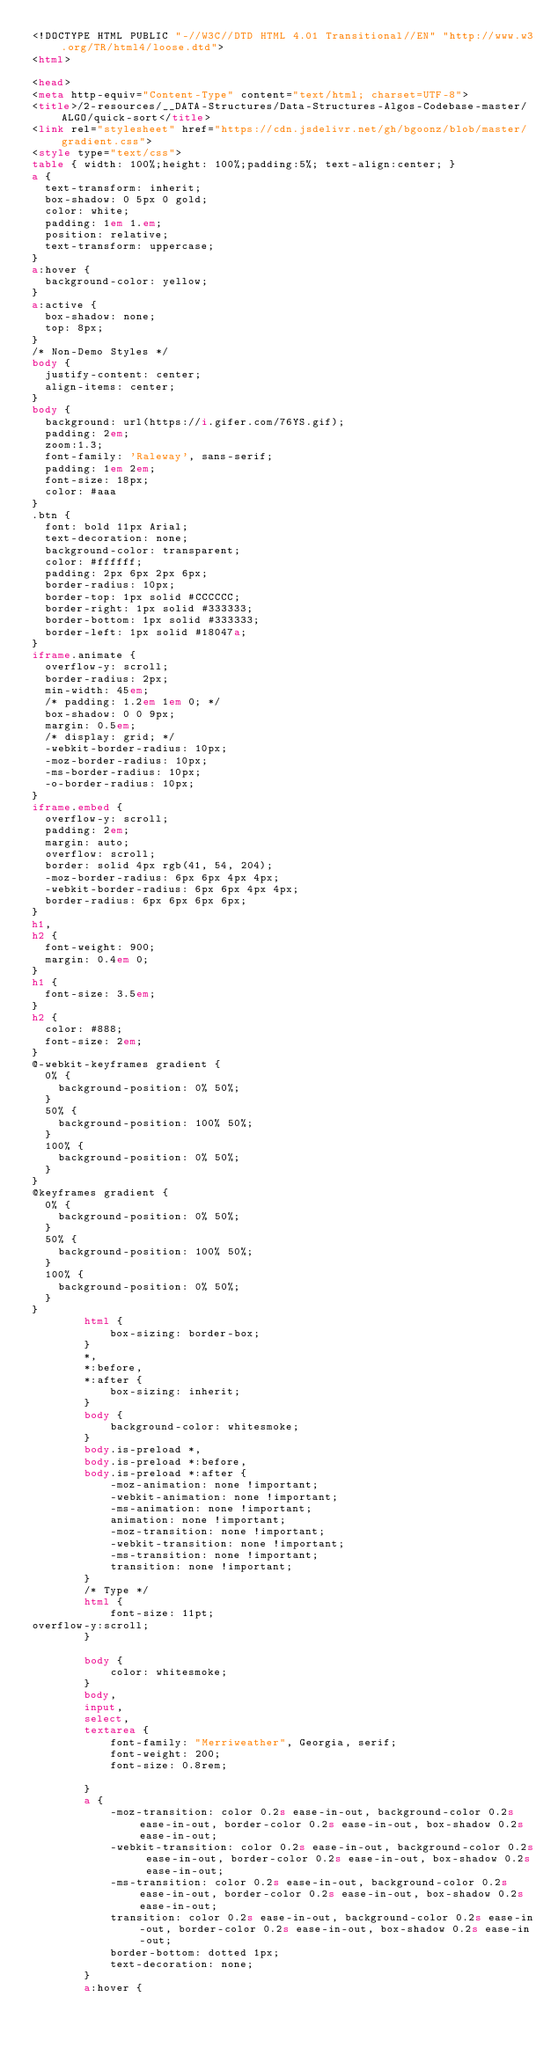Convert code to text. <code><loc_0><loc_0><loc_500><loc_500><_HTML_><!DOCTYPE HTML PUBLIC "-//W3C//DTD HTML 4.01 Transitional//EN" "http://www.w3.org/TR/html4/loose.dtd">
<html>

<head>
<meta http-equiv="Content-Type" content="text/html; charset=UTF-8">
<title>/2-resources/__DATA-Structures/Data-Structures-Algos-Codebase-master/ALGO/quick-sort</title>
<link rel="stylesheet" href="https://cdn.jsdelivr.net/gh/bgoonz/blob/master/gradient.css">
<style type="text/css">
table { width: 100%;height: 100%;padding:5%; text-align:center; }
a {
  text-transform: inherit;
  box-shadow: 0 5px 0 gold;
  color: white;
  padding: 1em 1.em;
  position: relative;
  text-transform: uppercase;
}
a:hover {
  background-color: yellow;
}
a:active {
  box-shadow: none;
  top: 8px;
}
/* Non-Demo Styles */
body {
  justify-content: center;
  align-items: center;
}
body {
  background: url(https://i.gifer.com/76YS.gif);
  padding: 2em;
  zoom:1.3;
  font-family: 'Raleway', sans-serif;
  padding: 1em 2em;
  font-size: 18px;
  color: #aaa
}
.btn {
  font: bold 11px Arial;
  text-decoration: none;
  background-color: transparent;
  color: #ffffff;
  padding: 2px 6px 2px 6px;
  border-radius: 10px;
  border-top: 1px solid #CCCCCC;
  border-right: 1px solid #333333;
  border-bottom: 1px solid #333333;
  border-left: 1px solid #18047a;
}
iframe.animate {
  overflow-y: scroll;
  border-radius: 2px;
  min-width: 45em;
  /* padding: 1.2em 1em 0; */
  box-shadow: 0 0 9px;
  margin: 0.5em;
  /* display: grid; */
  -webkit-border-radius: 10px;
  -moz-border-radius: 10px;
  -ms-border-radius: 10px;
  -o-border-radius: 10px;
}
iframe.embed {
  overflow-y: scroll;
  padding: 2em;
  margin: auto;
  overflow: scroll;
  border: solid 4px rgb(41, 54, 204);
  -moz-border-radius: 6px 6px 4px 4px;
  -webkit-border-radius: 6px 6px 4px 4px;
  border-radius: 6px 6px 6px 6px;
}
h1,
h2 {
  font-weight: 900;
  margin: 0.4em 0;
}
h1 {
  font-size: 3.5em;
}
h2 {
  color: #888;
  font-size: 2em;
}
@-webkit-keyframes gradient {
  0% {
    background-position: 0% 50%;
  }
  50% {
    background-position: 100% 50%;
  }
  100% {
    background-position: 0% 50%;
  }
}
@keyframes gradient {
  0% {
    background-position: 0% 50%;
  }
  50% {
    background-position: 100% 50%;
  }
  100% {
    background-position: 0% 50%;
  }
}
        html {
            box-sizing: border-box;
        }
        *,
        *:before,
        *:after {
            box-sizing: inherit;
        }
        body {
            background-color: whitesmoke;
        }
        body.is-preload *,
        body.is-preload *:before,
        body.is-preload *:after {
            -moz-animation: none !important;
            -webkit-animation: none !important;
            -ms-animation: none !important;
            animation: none !important;
            -moz-transition: none !important;
            -webkit-transition: none !important;
            -ms-transition: none !important;
            transition: none !important;
        }
        /* Type */
        html {
            font-size: 11pt;
overflow-y:scroll;
        }
       
        body {
            color: whitesmoke;
        }
        body,
        input,
        select,
        textarea {
            font-family: "Merriweather", Georgia, serif;
            font-weight: 200;
            font-size: 0.8rem;
          
        }
        a {
            -moz-transition: color 0.2s ease-in-out, background-color 0.2s ease-in-out, border-color 0.2s ease-in-out, box-shadow 0.2s ease-in-out;
            -webkit-transition: color 0.2s ease-in-out, background-color 0.2s ease-in-out, border-color 0.2s ease-in-out, box-shadow 0.2s ease-in-out;
            -ms-transition: color 0.2s ease-in-out, background-color 0.2s ease-in-out, border-color 0.2s ease-in-out, box-shadow 0.2s ease-in-out;
            transition: color 0.2s ease-in-out, background-color 0.2s ease-in-out, border-color 0.2s ease-in-out, box-shadow 0.2s ease-in-out;
            border-bottom: dotted 1px;
            text-decoration: none;
        }
        a:hover {</code> 